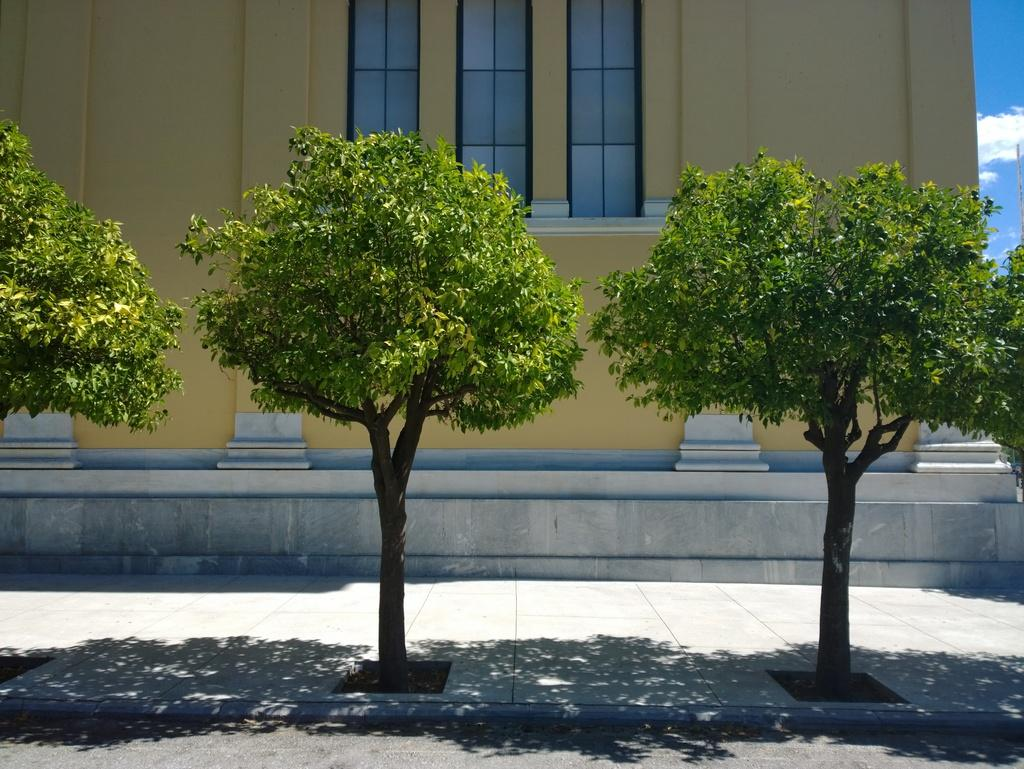What is located in the center of the image? There are trees in the center of the image. What can be seen in the background of the image? There is a building in the background of the image. How would you describe the sky in the image? The sky is cloudy in the image. What type of silver fang can be seen on the finger of the person in the image? There is no person or silver fang present in the image; it features trees and a building in the background. 